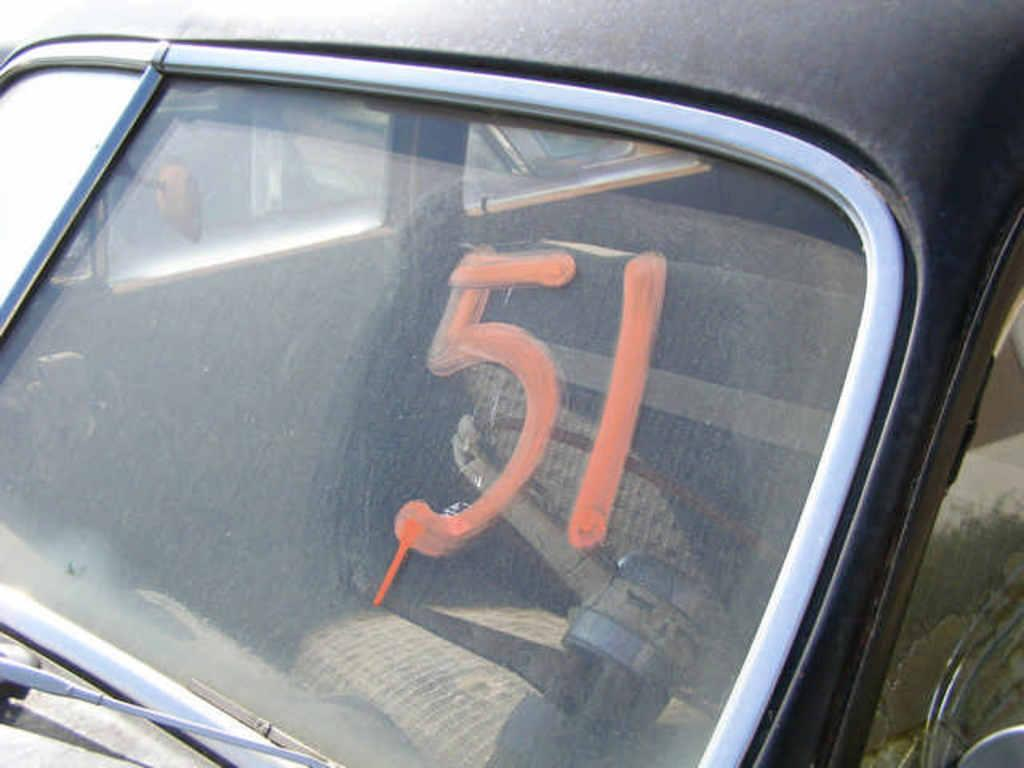What is the main subject of the image? The main subject of the image is the windshield of a car. Is there any text or numbers visible on the windshield? Yes, the number "501" is written on the windshield. How many sticks are being used for war in the image? There are no sticks or any indication of war present in the image. Can you see any playground equipment in the image? There is no playground equipment visible in the image; it features the windshield of a car. 